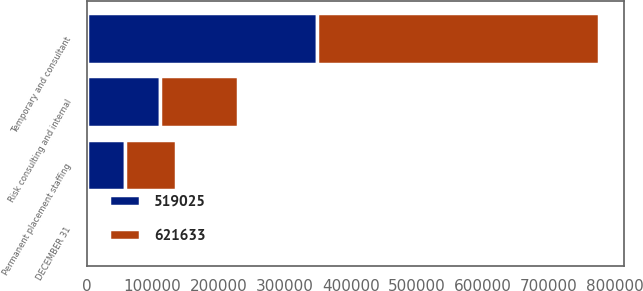Convert chart. <chart><loc_0><loc_0><loc_500><loc_500><stacked_bar_chart><ecel><fcel>DECEMBER 31<fcel>Temporary and consultant<fcel>Permanent placement staffing<fcel>Risk consulting and internal<nl><fcel>519025<fcel>2008<fcel>348946<fcel>58538<fcel>111541<nl><fcel>621633<fcel>2007<fcel>426731<fcel>77352<fcel>117550<nl></chart> 